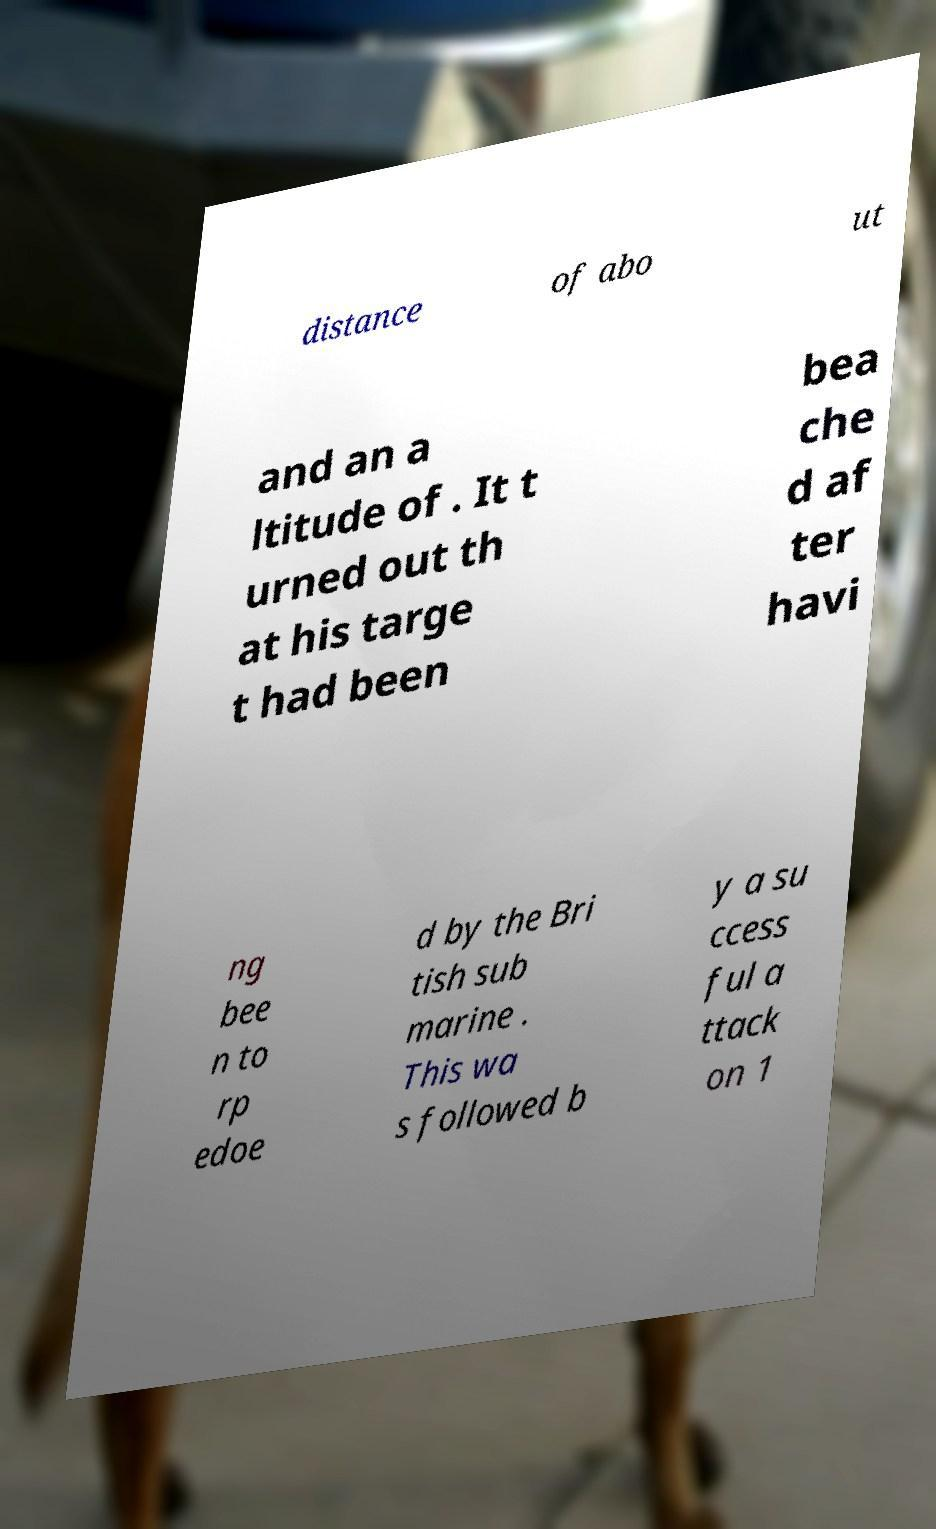Can you accurately transcribe the text from the provided image for me? distance of abo ut and an a ltitude of . It t urned out th at his targe t had been bea che d af ter havi ng bee n to rp edoe d by the Bri tish sub marine . This wa s followed b y a su ccess ful a ttack on 1 